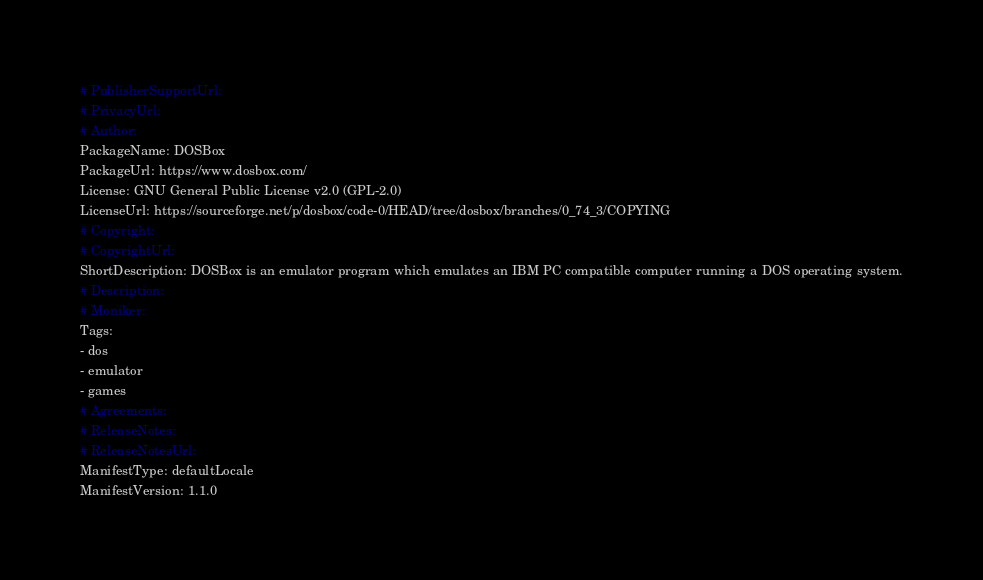<code> <loc_0><loc_0><loc_500><loc_500><_YAML_># PublisherSupportUrl: 
# PrivacyUrl: 
# Author: 
PackageName: DOSBox
PackageUrl: https://www.dosbox.com/
License: GNU General Public License v2.0 (GPL-2.0)
LicenseUrl: https://sourceforge.net/p/dosbox/code-0/HEAD/tree/dosbox/branches/0_74_3/COPYING
# Copyright: 
# CopyrightUrl: 
ShortDescription: DOSBox is an emulator program which emulates an IBM PC compatible computer running a DOS operating system.
# Description: 
# Moniker: 
Tags:
- dos
- emulator
- games
# Agreements: 
# ReleaseNotes: 
# ReleaseNotesUrl: 
ManifestType: defaultLocale
ManifestVersion: 1.1.0
</code> 